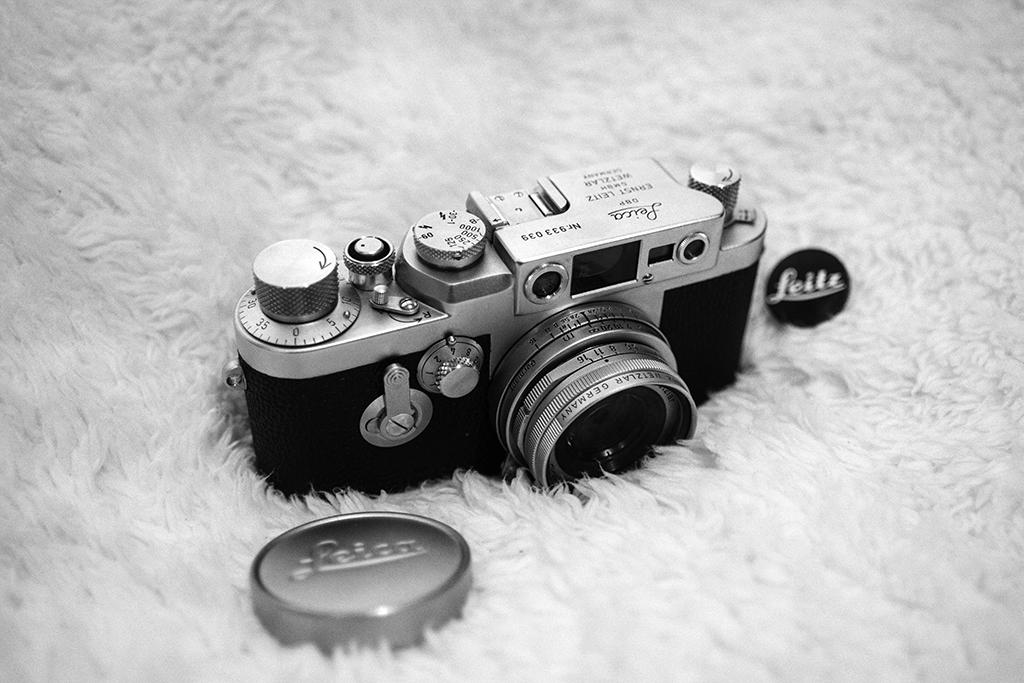What is the main object in the image? There is a camera in the image. What else can be seen in the image besides the camera? There are caps on a fur cloth in the image. What type of cloth is used to improve acoustics in the image? There is no cloth used to improve acoustics present in the image. How does the camera capture the sneeze of the person in the image? There is no person sneezing in the image, and the camera does not capture any sneezes. 